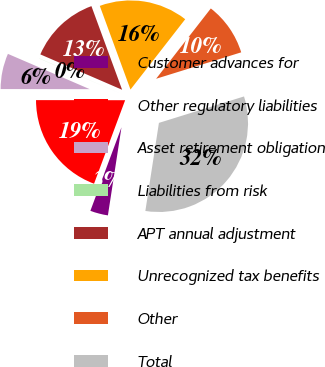Convert chart. <chart><loc_0><loc_0><loc_500><loc_500><pie_chart><fcel>Customer advances for<fcel>Other regulatory liabilities<fcel>Asset retirement obligation<fcel>Liabilities from risk<fcel>APT annual adjustment<fcel>Unrecognized tax benefits<fcel>Other<fcel>Total<nl><fcel>3.24%<fcel>19.34%<fcel>6.46%<fcel>0.02%<fcel>12.9%<fcel>16.12%<fcel>9.68%<fcel>32.22%<nl></chart> 